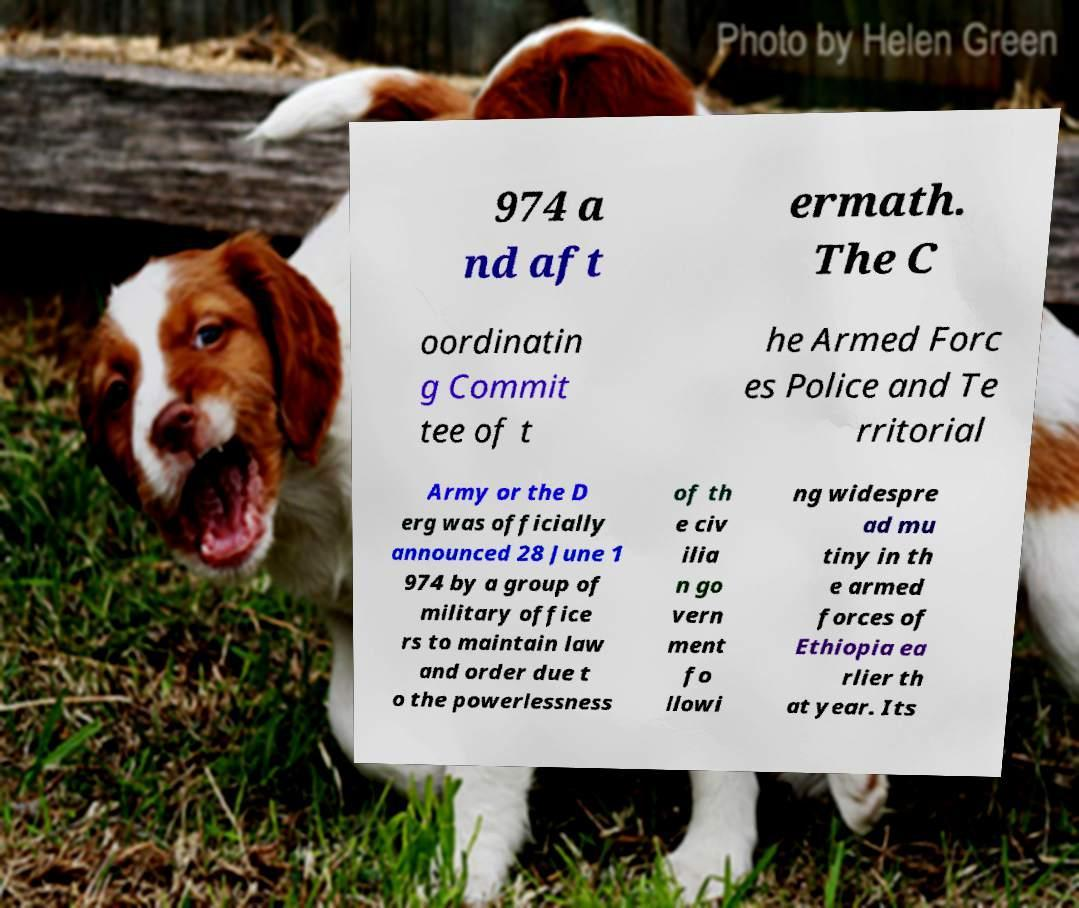Please read and relay the text visible in this image. What does it say? 974 a nd aft ermath. The C oordinatin g Commit tee of t he Armed Forc es Police and Te rritorial Army or the D erg was officially announced 28 June 1 974 by a group of military office rs to maintain law and order due t o the powerlessness of th e civ ilia n go vern ment fo llowi ng widespre ad mu tiny in th e armed forces of Ethiopia ea rlier th at year. Its 